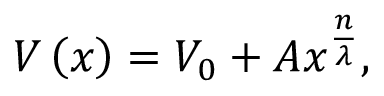<formula> <loc_0><loc_0><loc_500><loc_500>V \left ( x \right ) = V _ { 0 } + A x ^ { \frac { n } { \lambda } } ,</formula> 